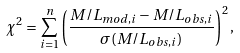Convert formula to latex. <formula><loc_0><loc_0><loc_500><loc_500>\chi ^ { 2 } = \sum _ { i = 1 } ^ { n } \left ( \frac { M / L _ { m o d , i } - M / L _ { o b s , i } } { \sigma ( M / L _ { o b s , i } ) } \right ) ^ { 2 } ,</formula> 